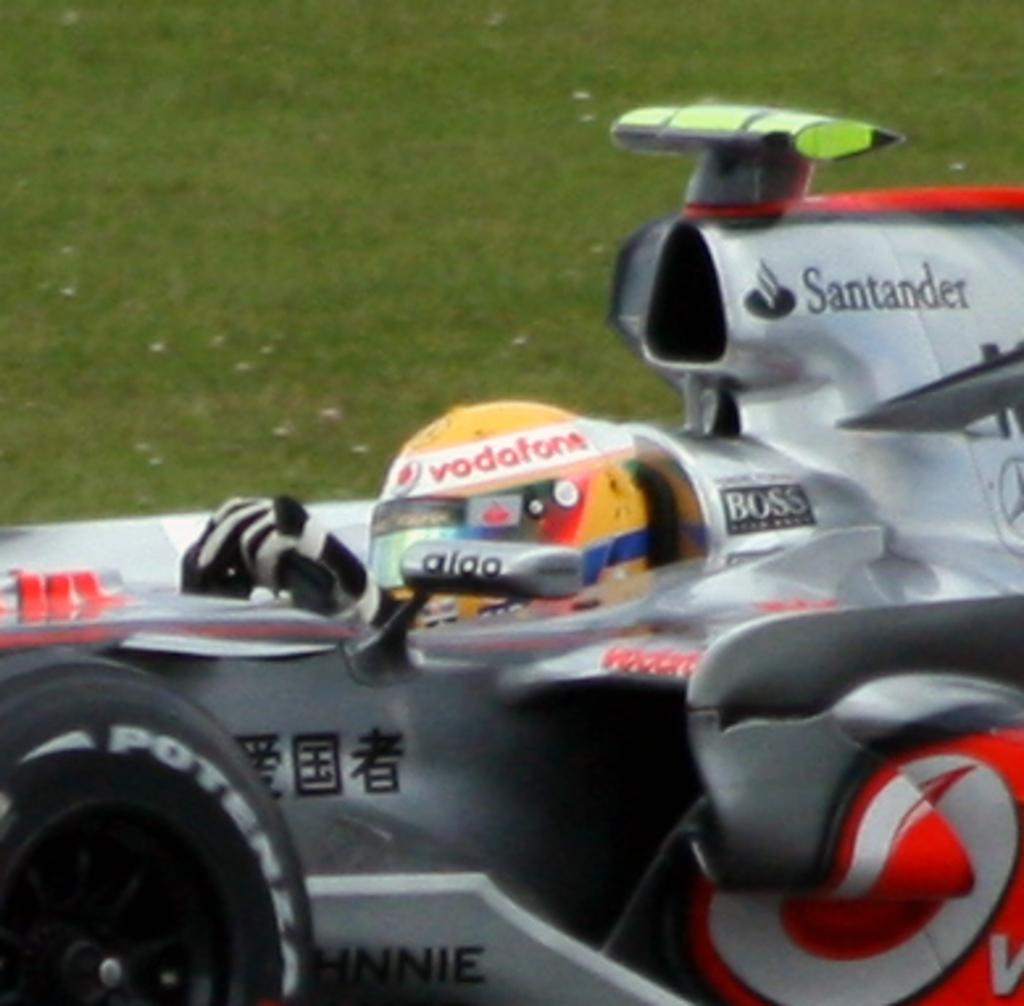Provide a one-sentence caption for the provided image. A motorized vehicle that says Boss and Santander. 